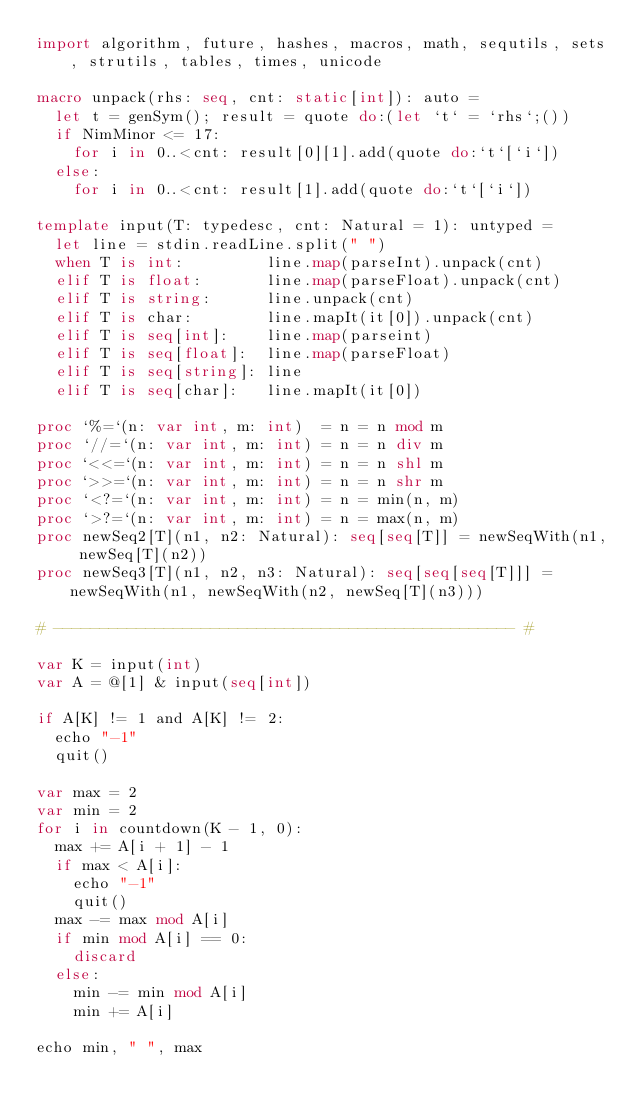<code> <loc_0><loc_0><loc_500><loc_500><_Nim_>import algorithm, future, hashes, macros, math, sequtils, sets, strutils, tables, times, unicode

macro unpack(rhs: seq, cnt: static[int]): auto =
  let t = genSym(); result = quote do:(let `t` = `rhs`;())
  if NimMinor <= 17:
    for i in 0..<cnt: result[0][1].add(quote do:`t`[`i`])
  else:
    for i in 0..<cnt: result[1].add(quote do:`t`[`i`])

template input(T: typedesc, cnt: Natural = 1): untyped =
  let line = stdin.readLine.split(" ")
  when T is int:         line.map(parseInt).unpack(cnt)
  elif T is float:       line.map(parseFloat).unpack(cnt)
  elif T is string:      line.unpack(cnt)
  elif T is char:        line.mapIt(it[0]).unpack(cnt)
  elif T is seq[int]:    line.map(parseint)
  elif T is seq[float]:  line.map(parseFloat)
  elif T is seq[string]: line
  elif T is seq[char]:   line.mapIt(it[0])

proc `%=`(n: var int, m: int)  = n = n mod m
proc `//=`(n: var int, m: int) = n = n div m
proc `<<=`(n: var int, m: int) = n = n shl m
proc `>>=`(n: var int, m: int) = n = n shr m
proc `<?=`(n: var int, m: int) = n = min(n, m)
proc `>?=`(n: var int, m: int) = n = max(n, m)
proc newSeq2[T](n1, n2: Natural): seq[seq[T]] = newSeqWith(n1, newSeq[T](n2))
proc newSeq3[T](n1, n2, n3: Natural): seq[seq[seq[T]]] = newSeqWith(n1, newSeqWith(n2, newSeq[T](n3)))

# -------------------------------------------------- #

var K = input(int)
var A = @[1] & input(seq[int])

if A[K] != 1 and A[K] != 2:
  echo "-1"
  quit()

var max = 2
var min = 2
for i in countdown(K - 1, 0):
  max += A[i + 1] - 1
  if max < A[i]:
    echo "-1"
    quit()
  max -= max mod A[i]
  if min mod A[i] == 0:
    discard
  else:
    min -= min mod A[i]
    min += A[i]

echo min, " ", max</code> 